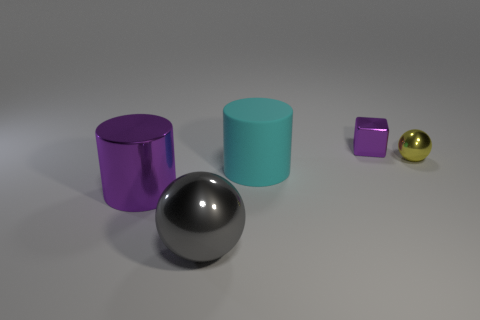There is a large object on the right side of the sphere that is left of the small purple metallic cube; are there any objects behind it?
Keep it short and to the point. Yes. There is another thing that is the same shape as the big cyan thing; what size is it?
Offer a very short reply. Large. Is there anything else that has the same material as the gray object?
Your response must be concise. Yes. Are there any purple metallic objects?
Offer a terse response. Yes. There is a shiny cube; is its color the same as the metallic sphere that is to the left of the large cyan matte cylinder?
Offer a very short reply. No. How big is the purple metal object that is behind the cylinder that is behind the big shiny object that is behind the gray metallic ball?
Your answer should be very brief. Small. How many blocks have the same color as the shiny cylinder?
Give a very brief answer. 1. What number of objects are tiny spheres or big cylinders that are to the left of the cyan cylinder?
Provide a succinct answer. 2. What color is the matte cylinder?
Ensure brevity in your answer.  Cyan. What is the color of the big cylinder that is behind the large purple cylinder?
Your answer should be very brief. Cyan. 